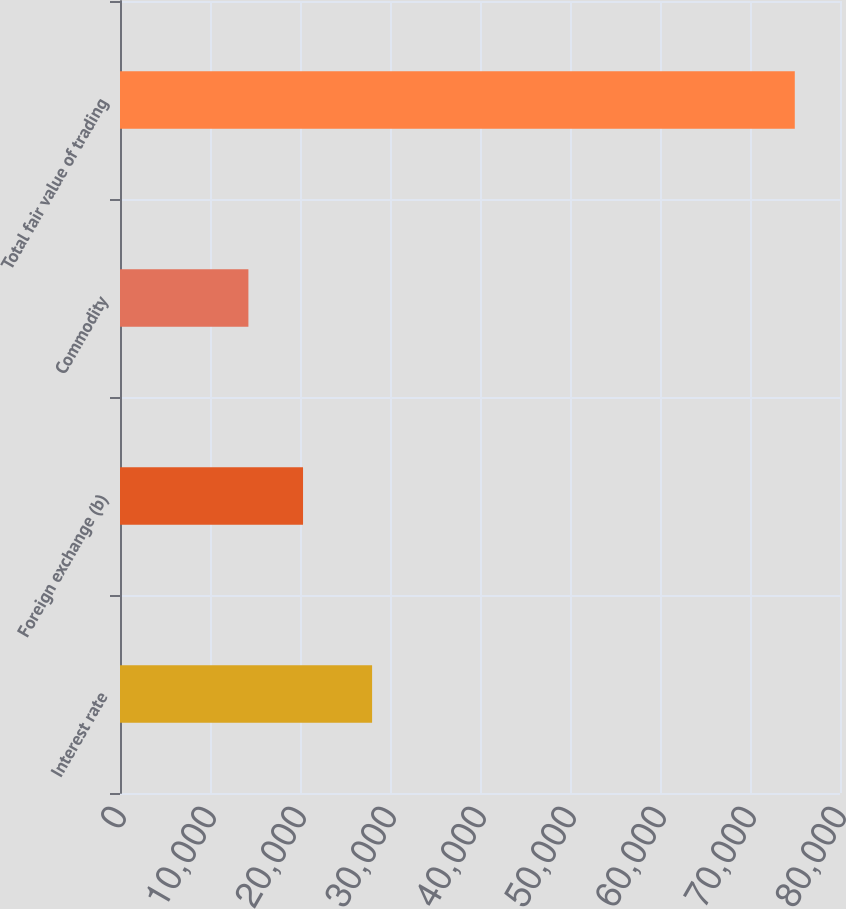<chart> <loc_0><loc_0><loc_500><loc_500><bar_chart><fcel>Interest rate<fcel>Foreign exchange (b)<fcel>Commodity<fcel>Total fair value of trading<nl><fcel>28010<fcel>20338<fcel>14267<fcel>74977<nl></chart> 